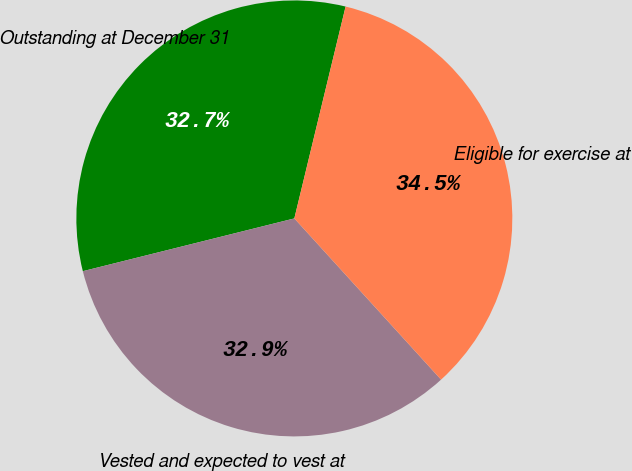Convert chart to OTSL. <chart><loc_0><loc_0><loc_500><loc_500><pie_chart><fcel>Outstanding at December 31<fcel>Vested and expected to vest at<fcel>Eligible for exercise at<nl><fcel>32.67%<fcel>32.86%<fcel>34.47%<nl></chart> 